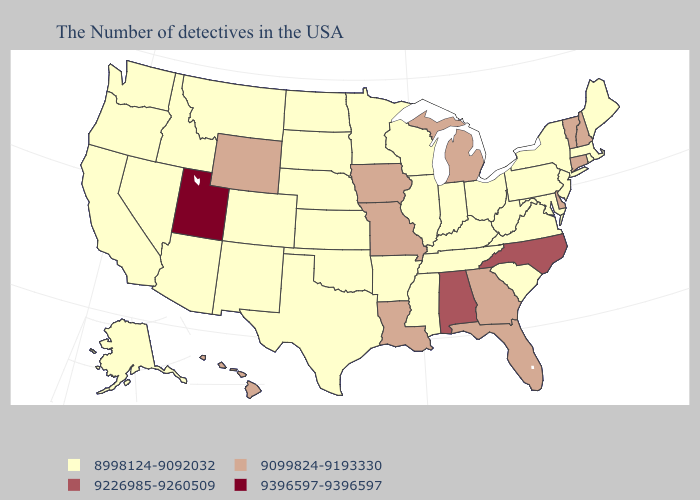Among the states that border South Carolina , does Georgia have the lowest value?
Give a very brief answer. Yes. Name the states that have a value in the range 9396597-9396597?
Keep it brief. Utah. Does the first symbol in the legend represent the smallest category?
Quick response, please. Yes. What is the value of Washington?
Short answer required. 8998124-9092032. Name the states that have a value in the range 9099824-9193330?
Short answer required. New Hampshire, Vermont, Connecticut, Delaware, Florida, Georgia, Michigan, Louisiana, Missouri, Iowa, Wyoming, Hawaii. What is the value of Oklahoma?
Answer briefly. 8998124-9092032. Which states have the lowest value in the USA?
Short answer required. Maine, Massachusetts, Rhode Island, New York, New Jersey, Maryland, Pennsylvania, Virginia, South Carolina, West Virginia, Ohio, Kentucky, Indiana, Tennessee, Wisconsin, Illinois, Mississippi, Arkansas, Minnesota, Kansas, Nebraska, Oklahoma, Texas, South Dakota, North Dakota, Colorado, New Mexico, Montana, Arizona, Idaho, Nevada, California, Washington, Oregon, Alaska. What is the highest value in states that border Maine?
Concise answer only. 9099824-9193330. Name the states that have a value in the range 8998124-9092032?
Be succinct. Maine, Massachusetts, Rhode Island, New York, New Jersey, Maryland, Pennsylvania, Virginia, South Carolina, West Virginia, Ohio, Kentucky, Indiana, Tennessee, Wisconsin, Illinois, Mississippi, Arkansas, Minnesota, Kansas, Nebraska, Oklahoma, Texas, South Dakota, North Dakota, Colorado, New Mexico, Montana, Arizona, Idaho, Nevada, California, Washington, Oregon, Alaska. Among the states that border Kansas , which have the highest value?
Keep it brief. Missouri. What is the lowest value in the Northeast?
Answer briefly. 8998124-9092032. Which states have the lowest value in the Northeast?
Concise answer only. Maine, Massachusetts, Rhode Island, New York, New Jersey, Pennsylvania. Name the states that have a value in the range 9396597-9396597?
Concise answer only. Utah. Among the states that border Utah , does Wyoming have the lowest value?
Write a very short answer. No. 